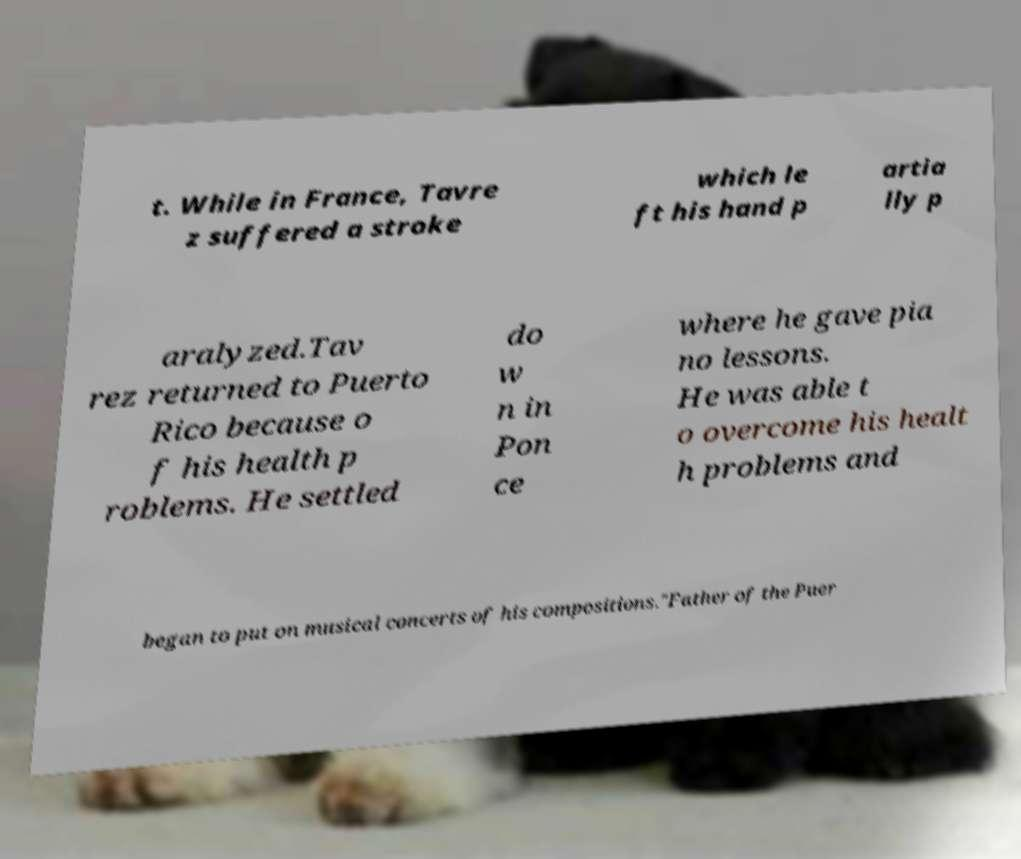Could you extract and type out the text from this image? t. While in France, Tavre z suffered a stroke which le ft his hand p artia lly p aralyzed.Tav rez returned to Puerto Rico because o f his health p roblems. He settled do w n in Pon ce where he gave pia no lessons. He was able t o overcome his healt h problems and began to put on musical concerts of his compositions."Father of the Puer 